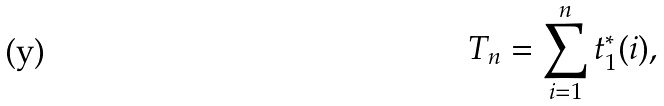<formula> <loc_0><loc_0><loc_500><loc_500>T _ { n } = \sum _ { i = 1 } ^ { n } t ^ { * } _ { 1 } ( i ) ,</formula> 